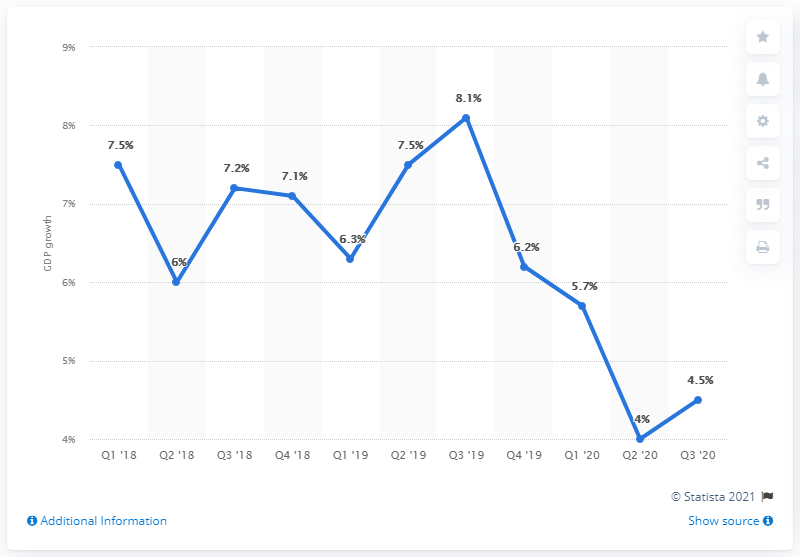Indicate a few pertinent items in this graphic. In the third quarter of 2019, the Gross Domestic Product (GDP) was the highest it has been to date. The sum of Q2'20 and Q3'20 is 8.5. 